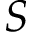<formula> <loc_0><loc_0><loc_500><loc_500>S</formula> 